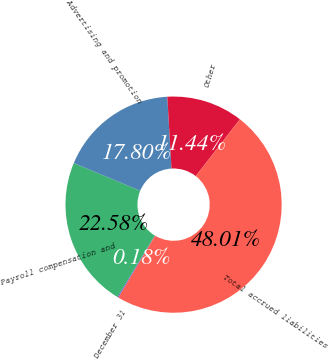Convert chart. <chart><loc_0><loc_0><loc_500><loc_500><pie_chart><fcel>December 31<fcel>Payroll compensation and<fcel>Advertising and promotion<fcel>Other<fcel>Total accrued liabilities<nl><fcel>0.18%<fcel>22.58%<fcel>17.8%<fcel>11.44%<fcel>48.01%<nl></chart> 